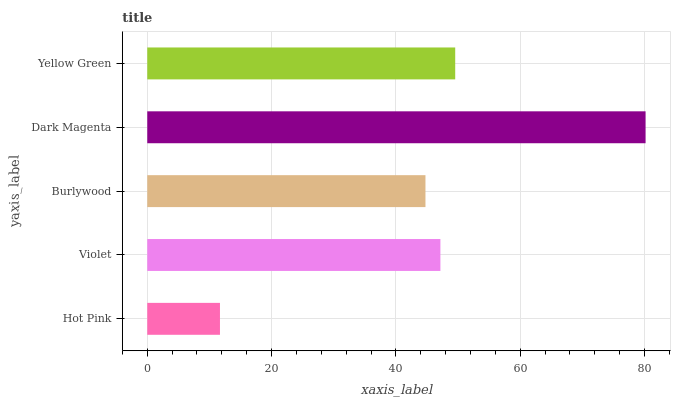Is Hot Pink the minimum?
Answer yes or no. Yes. Is Dark Magenta the maximum?
Answer yes or no. Yes. Is Violet the minimum?
Answer yes or no. No. Is Violet the maximum?
Answer yes or no. No. Is Violet greater than Hot Pink?
Answer yes or no. Yes. Is Hot Pink less than Violet?
Answer yes or no. Yes. Is Hot Pink greater than Violet?
Answer yes or no. No. Is Violet less than Hot Pink?
Answer yes or no. No. Is Violet the high median?
Answer yes or no. Yes. Is Violet the low median?
Answer yes or no. Yes. Is Burlywood the high median?
Answer yes or no. No. Is Dark Magenta the low median?
Answer yes or no. No. 